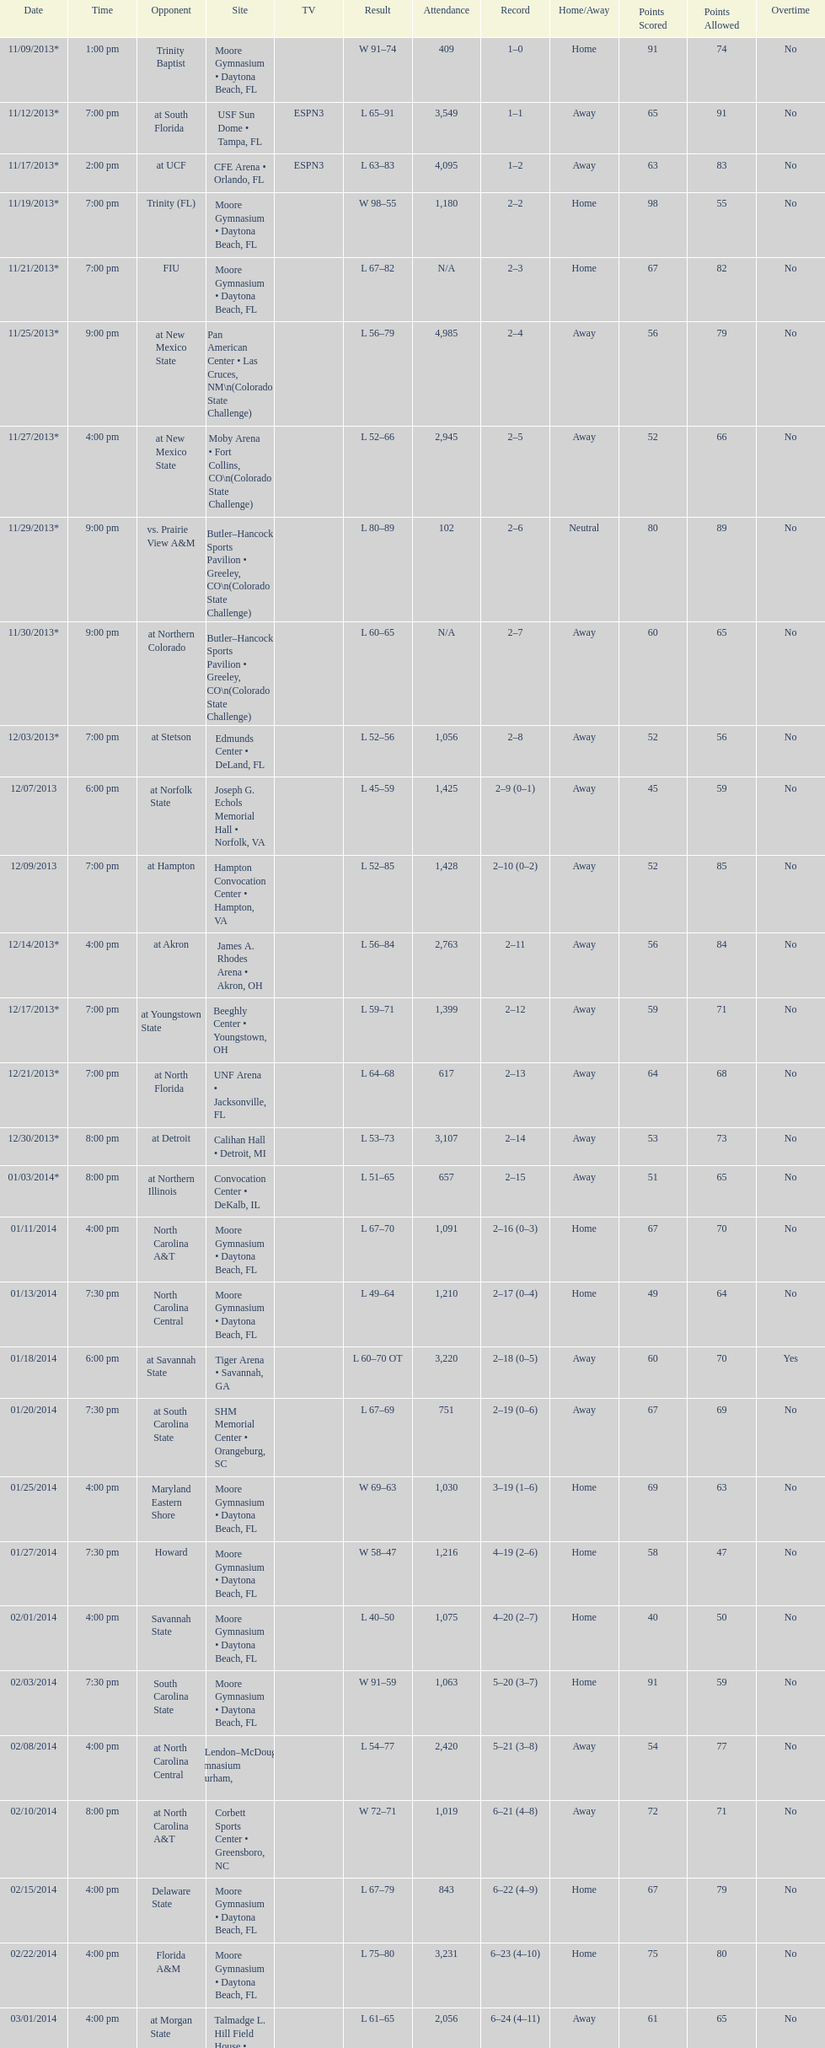How many games had more than 1,500 in attendance? 12. 